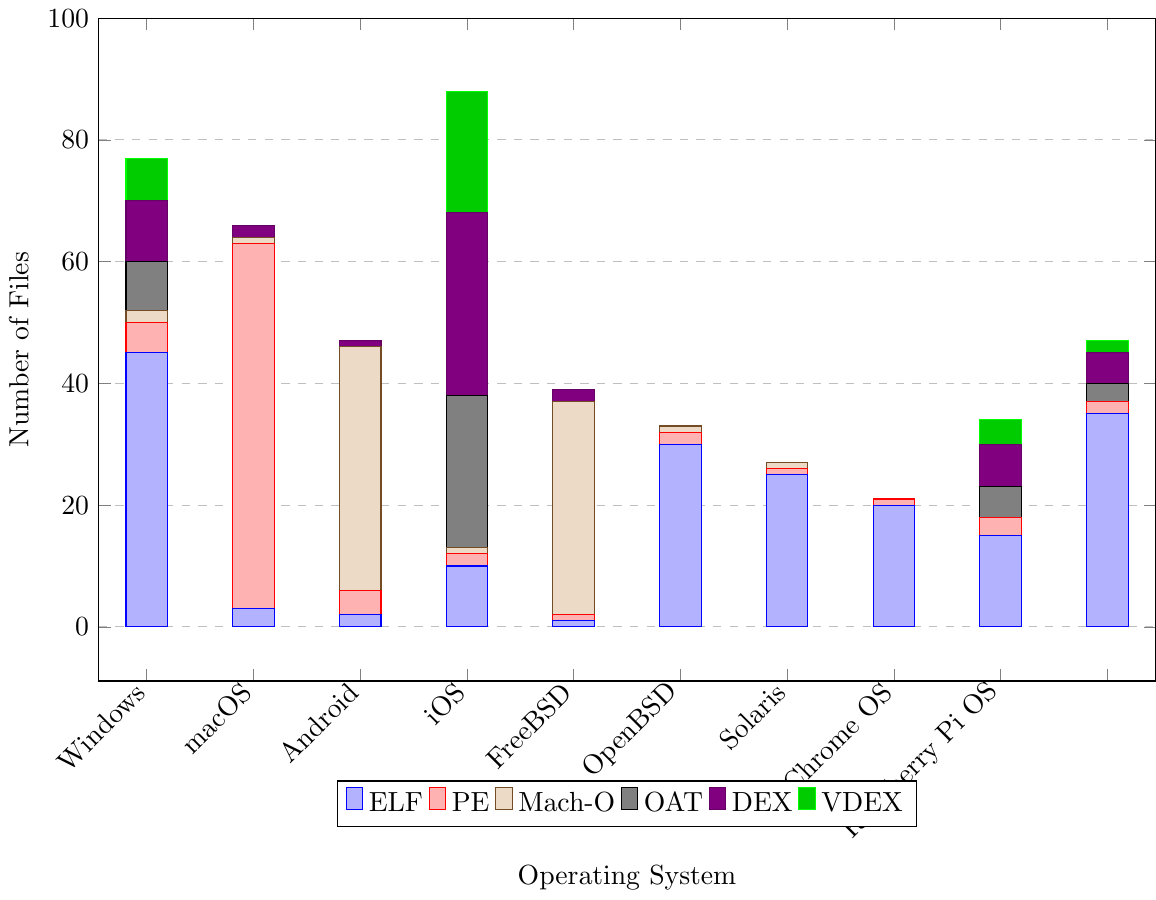Which operating system has the highest number of PE files? By examining the heights of the bars corresponding to PE files across different operating systems, the tallest bar is for Windows. This indicates that Windows has the highest number of PE files.
Answer: Windows Which file format is most frequently analyzed on Android? The tallest bar in the Android category corresponds to the DEX file format.
Answer: DEX How many total ELF files are analyzed across all operating systems? Sum the heights of all ELF bars: 45 (Linux) + 3 (Windows) + 2 (macOS) + 10 (Android) + 1 (iOS) + 30 (FreeBSD) + 25 (OpenBSD) + 20 (Solaris) + 15 (Chrome OS) + 35 (Raspberry Pi OS) = 186.
Answer: 186 Which operating systems do not analyze OAT files? Identify categories with no bar for OAT files: Windows, macOS, iOS, FreeBSD, OpenBSD, Solaris.
Answer: Windows, macOS, iOS, FreeBSD, OpenBSD, Solaris Compare the number of Mach-O files analyzed on macOS and iOS. Check the bar heights for Mach-O files for both operating systems. macOS has a taller bar (40) compared to iOS (35), so macOS analyzes more Mach-O files.
Answer: macOS What is the combined number of VDEX and DEX files on Chrome OS? Sum the heights of the VDEX and DEX bars for Chrome OS: 4 (VDEX) + 7 (DEX) = 11.
Answer: 11 Which operating system exclusively analyzes ELF files without touching any OAT, DEX, or VDEX files? Look for an operating system with only ELF files and no bars for OAT, DEX or VDEX. OpenBSD exclusively shows ELF files with no OAT, DEX, or VDEX bars.
Answer: OpenBSD What is the total number of executable files analyzed for Linux? Sum the heights of all bars for Linux: 45 (ELF) + 5 (PE) + 2 (Mach-O) + 8 (OAT) + 10 (DEX) + 7 (VDEX) = 77.
Answer: 77 How many more PE files does Windows analyze compared to Linux? Subtract the number of PE files for Linux from the number for Windows: 60 (Windows) - 5 (Linux) = 55.
Answer: 55 What is the least common file format analyzed across all operating systems? Each bar's heights are examined; the least frequently occurring format (smallest total sum of bars) is Mach-O. Summing bars: 2 + 1 + 40 + 1 + 35 + 1 + 1 + 0 + 0 + 0 = 81.
Answer: Mach-O 